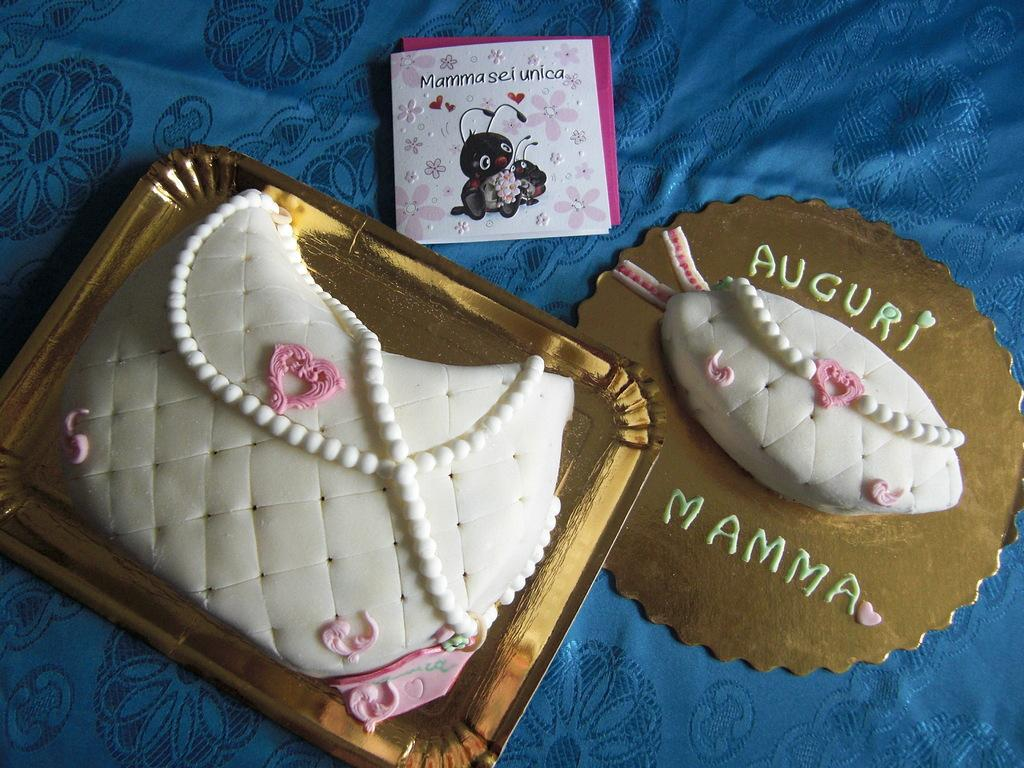What type of dessert can be seen in the image? There are two white cakes in the image. Where are the cakes located? The cakes are placed on a table. What color is the tablecloth covering the table? The table is covered with a blue cloth. What other item can be seen beside the cakes? There is a greeting card beside the cakes. What type of structure is being destroyed in the image? There is no structure being destroyed in the image; it features two white cakes on a table. What additional dessert is being added to the table in the image? There is no additional dessert being added to the table in the image; it only shows two white cakes and a greeting card. 